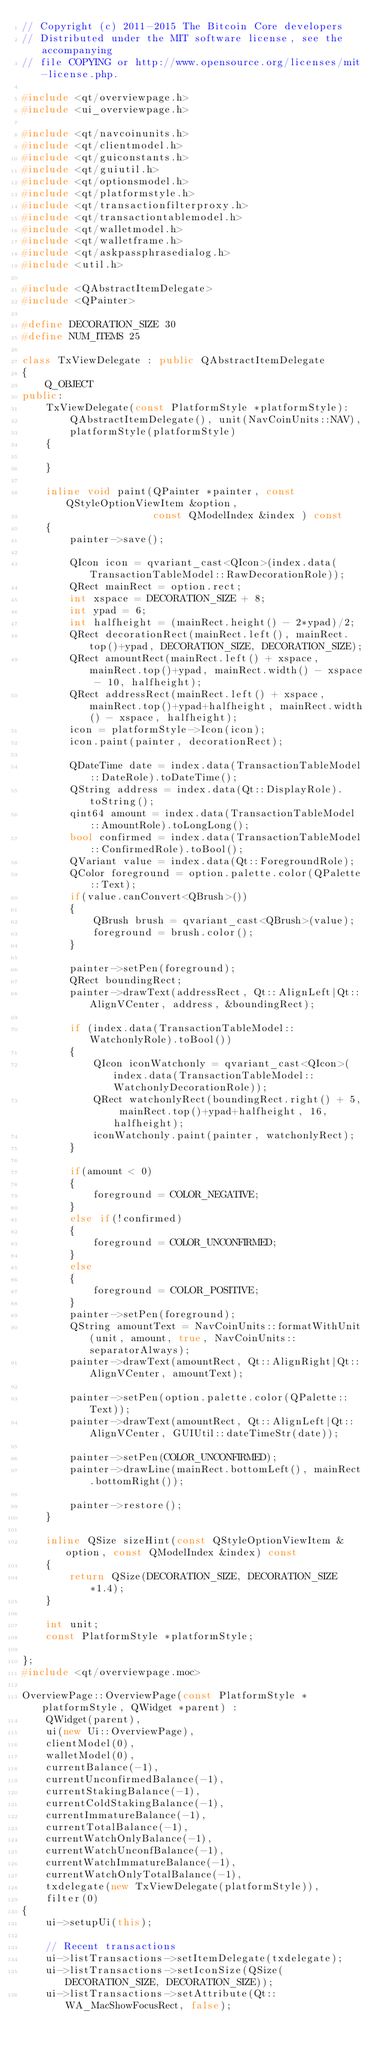Convert code to text. <code><loc_0><loc_0><loc_500><loc_500><_C++_>// Copyright (c) 2011-2015 The Bitcoin Core developers
// Distributed under the MIT software license, see the accompanying
// file COPYING or http://www.opensource.org/licenses/mit-license.php.

#include <qt/overviewpage.h>
#include <ui_overviewpage.h>

#include <qt/navcoinunits.h>
#include <qt/clientmodel.h>
#include <qt/guiconstants.h>
#include <qt/guiutil.h>
#include <qt/optionsmodel.h>
#include <qt/platformstyle.h>
#include <qt/transactionfilterproxy.h>
#include <qt/transactiontablemodel.h>
#include <qt/walletmodel.h>
#include <qt/walletframe.h>
#include <qt/askpassphrasedialog.h>
#include <util.h>

#include <QAbstractItemDelegate>
#include <QPainter>

#define DECORATION_SIZE 30
#define NUM_ITEMS 25

class TxViewDelegate : public QAbstractItemDelegate
{
    Q_OBJECT
public:
    TxViewDelegate(const PlatformStyle *platformStyle):
        QAbstractItemDelegate(), unit(NavCoinUnits::NAV),
        platformStyle(platformStyle)
    {

    }

    inline void paint(QPainter *painter, const QStyleOptionViewItem &option,
                      const QModelIndex &index ) const
    {
        painter->save();

        QIcon icon = qvariant_cast<QIcon>(index.data(TransactionTableModel::RawDecorationRole));
        QRect mainRect = option.rect;
        int xspace = DECORATION_SIZE + 8;
        int ypad = 6;
        int halfheight = (mainRect.height() - 2*ypad)/2;
        QRect decorationRect(mainRect.left(), mainRect.top()+ypad, DECORATION_SIZE, DECORATION_SIZE);
        QRect amountRect(mainRect.left() + xspace, mainRect.top()+ypad, mainRect.width() - xspace - 10, halfheight);
        QRect addressRect(mainRect.left() + xspace, mainRect.top()+ypad+halfheight, mainRect.width() - xspace, halfheight);
        icon = platformStyle->Icon(icon);
        icon.paint(painter, decorationRect);

        QDateTime date = index.data(TransactionTableModel::DateRole).toDateTime();
        QString address = index.data(Qt::DisplayRole).toString();
        qint64 amount = index.data(TransactionTableModel::AmountRole).toLongLong();
        bool confirmed = index.data(TransactionTableModel::ConfirmedRole).toBool();
        QVariant value = index.data(Qt::ForegroundRole);
        QColor foreground = option.palette.color(QPalette::Text);
        if(value.canConvert<QBrush>())
        {
            QBrush brush = qvariant_cast<QBrush>(value);
            foreground = brush.color();
        }

        painter->setPen(foreground);
        QRect boundingRect;
        painter->drawText(addressRect, Qt::AlignLeft|Qt::AlignVCenter, address, &boundingRect);

        if (index.data(TransactionTableModel::WatchonlyRole).toBool())
        {
            QIcon iconWatchonly = qvariant_cast<QIcon>(index.data(TransactionTableModel::WatchonlyDecorationRole));
            QRect watchonlyRect(boundingRect.right() + 5, mainRect.top()+ypad+halfheight, 16, halfheight);
            iconWatchonly.paint(painter, watchonlyRect);
        }

        if(amount < 0)
        {
            foreground = COLOR_NEGATIVE;
        }
        else if(!confirmed)
        {
            foreground = COLOR_UNCONFIRMED;
        }
        else
        {
            foreground = COLOR_POSITIVE;
        }
        painter->setPen(foreground);
        QString amountText = NavCoinUnits::formatWithUnit(unit, amount, true, NavCoinUnits::separatorAlways);
        painter->drawText(amountRect, Qt::AlignRight|Qt::AlignVCenter, amountText);

        painter->setPen(option.palette.color(QPalette::Text));
        painter->drawText(amountRect, Qt::AlignLeft|Qt::AlignVCenter, GUIUtil::dateTimeStr(date));

        painter->setPen(COLOR_UNCONFIRMED);
        painter->drawLine(mainRect.bottomLeft(), mainRect.bottomRight());

        painter->restore();
    }

    inline QSize sizeHint(const QStyleOptionViewItem &option, const QModelIndex &index) const
    {
        return QSize(DECORATION_SIZE, DECORATION_SIZE*1.4);
    }

    int unit;
    const PlatformStyle *platformStyle;

};
#include <qt/overviewpage.moc>

OverviewPage::OverviewPage(const PlatformStyle *platformStyle, QWidget *parent) :
    QWidget(parent),
    ui(new Ui::OverviewPage),
    clientModel(0),
    walletModel(0),
    currentBalance(-1),
    currentUnconfirmedBalance(-1),
    currentStakingBalance(-1),
    currentColdStakingBalance(-1),
    currentImmatureBalance(-1),
    currentTotalBalance(-1),
    currentWatchOnlyBalance(-1),
    currentWatchUnconfBalance(-1),
    currentWatchImmatureBalance(-1),
    currentWatchOnlyTotalBalance(-1),
    txdelegate(new TxViewDelegate(platformStyle)),
    filter(0)
{
    ui->setupUi(this);

    // Recent transactions
    ui->listTransactions->setItemDelegate(txdelegate);
    ui->listTransactions->setIconSize(QSize(DECORATION_SIZE, DECORATION_SIZE));
    ui->listTransactions->setAttribute(Qt::WA_MacShowFocusRect, false);
</code> 